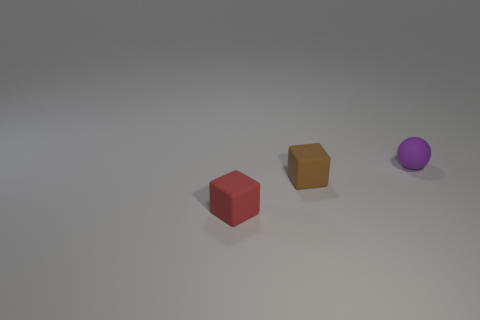How many blocks are right of the matte object that is in front of the rubber block right of the tiny red block?
Your answer should be very brief. 1. Does the tiny block right of the red thing have the same material as the tiny red object?
Provide a succinct answer. Yes. The other object that is the same shape as the brown rubber object is what color?
Your answer should be compact. Red. What number of other objects are there of the same color as the rubber sphere?
Offer a very short reply. 0. There is a tiny brown rubber object behind the red cube; does it have the same shape as the rubber object that is right of the small brown thing?
Your response must be concise. No. What number of spheres are brown things or red objects?
Your answer should be compact. 0. Is the number of small brown cubes that are in front of the tiny brown cube less than the number of tiny rubber spheres?
Provide a succinct answer. Yes. How many other objects are the same material as the sphere?
Give a very brief answer. 2. Is the brown rubber cube the same size as the red block?
Make the answer very short. Yes. How many objects are either tiny purple spheres behind the small red thing or small red rubber blocks?
Your response must be concise. 2. 